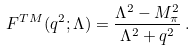<formula> <loc_0><loc_0><loc_500><loc_500>F ^ { T M } ( q ^ { 2 } ; \Lambda ) = \frac { \Lambda ^ { 2 } - M _ { \pi } ^ { 2 } } { \Lambda ^ { 2 } + q ^ { 2 } } \, .</formula> 